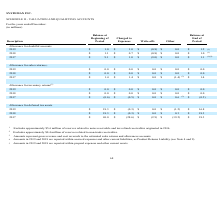According to Systemax's financial document, What is excluded from the 2019 allowance for doubtful accounts? approximately $5.6 million of reserves related to notes receivable and tax refund receivables originated in 2016.. The document states: "1 Excludes approximately $5.6 million of reserves related to notes receivable and tax refund receivables originated in 2016...." Also, What are excluded from the 2017 allowance for doubtful accounts? The document shows two values: approximately $5.6 million of reserves related to notes receivable and tax refund receivables originated in 2016 and approximately $0.4 million of reserves related to non-trade receivables.. From the document: "1 Excludes approximately $5.6 million of reserves related to notes receivable and tax refund receivables originated in 2016. 2 Excludes approximately ..." Also, What does the "other" description in allowance for sales return in 2017 refer to? gross revenue and cost reversals to the estimated sales returns and allowances accounts.. The document states: "3 Amounts represent gross revenue and cost reversals to the estimated sales returns and allowances accounts...." Also, can you calculate: What is the total allowance for doubtful accounts charged to expenses between 2017 to 2019? Based on the calculation: $1.0 + $0.7 + $1.0 , the result is 2.7 (in millions). This is based on the information: "2019 $ 1.0 $ 1.0 $ (0.8) $ 0.0 $ 1.2 (1) 2018 $ 1.1 $ 0.7 $ (0.8) $ 0.0 $ 1.0 (1)..." The key data points involved are: 0.7, 1.0. Also, can you calculate: What is the total allowances for sales returns write-offs between 2017 to 2019? I cannot find a specific answer to this question in the financial document. Also, can you calculate: What is the percentage change in the allowance for deferred tax assets at the end of period between 2018 and 2019? To answer this question, I need to perform calculations using the financial data. The calculation is: (16.8 - 18.3)/18.3 , which equals -8.2 (percentage). This is based on the information: "2019 $ 18.3 $ (0.3) $ 0.0 $ (1.2) $ 16.8 2019 $ 18.3 $ (0.3) $ 0.0 $ (1.2) $ 16.8..." The key data points involved are: 16.8, 18.3. 